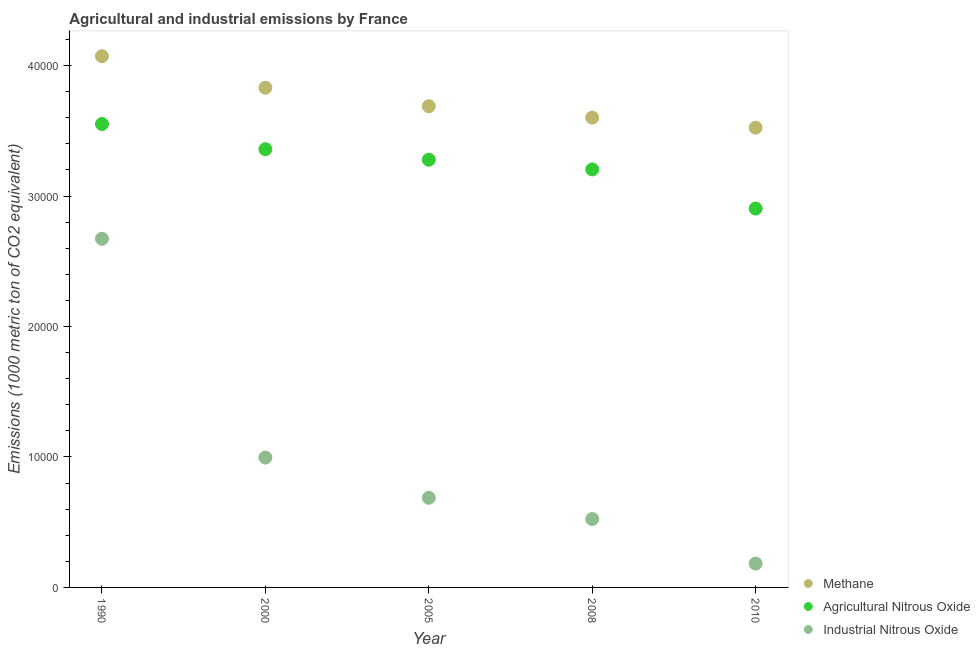How many different coloured dotlines are there?
Give a very brief answer. 3. Is the number of dotlines equal to the number of legend labels?
Your response must be concise. Yes. What is the amount of agricultural nitrous oxide emissions in 2005?
Make the answer very short. 3.28e+04. Across all years, what is the maximum amount of industrial nitrous oxide emissions?
Ensure brevity in your answer.  2.67e+04. Across all years, what is the minimum amount of methane emissions?
Ensure brevity in your answer.  3.52e+04. In which year was the amount of agricultural nitrous oxide emissions maximum?
Keep it short and to the point. 1990. In which year was the amount of industrial nitrous oxide emissions minimum?
Offer a very short reply. 2010. What is the total amount of methane emissions in the graph?
Your answer should be compact. 1.87e+05. What is the difference between the amount of industrial nitrous oxide emissions in 2005 and that in 2010?
Your response must be concise. 5042.8. What is the difference between the amount of methane emissions in 1990 and the amount of agricultural nitrous oxide emissions in 2000?
Your response must be concise. 7128.7. What is the average amount of agricultural nitrous oxide emissions per year?
Provide a succinct answer. 3.26e+04. In the year 1990, what is the difference between the amount of industrial nitrous oxide emissions and amount of agricultural nitrous oxide emissions?
Provide a short and direct response. -8797.6. In how many years, is the amount of agricultural nitrous oxide emissions greater than 12000 metric ton?
Your answer should be compact. 5. What is the ratio of the amount of agricultural nitrous oxide emissions in 1990 to that in 2010?
Keep it short and to the point. 1.22. Is the difference between the amount of industrial nitrous oxide emissions in 2000 and 2005 greater than the difference between the amount of agricultural nitrous oxide emissions in 2000 and 2005?
Keep it short and to the point. Yes. What is the difference between the highest and the second highest amount of industrial nitrous oxide emissions?
Make the answer very short. 1.68e+04. What is the difference between the highest and the lowest amount of agricultural nitrous oxide emissions?
Ensure brevity in your answer.  6479.5. Is the sum of the amount of methane emissions in 2005 and 2010 greater than the maximum amount of industrial nitrous oxide emissions across all years?
Offer a very short reply. Yes. Is the amount of industrial nitrous oxide emissions strictly greater than the amount of methane emissions over the years?
Your answer should be very brief. No. Is the amount of methane emissions strictly less than the amount of agricultural nitrous oxide emissions over the years?
Give a very brief answer. No. How many years are there in the graph?
Your answer should be compact. 5. Does the graph contain any zero values?
Ensure brevity in your answer.  No. Where does the legend appear in the graph?
Provide a short and direct response. Bottom right. How are the legend labels stacked?
Give a very brief answer. Vertical. What is the title of the graph?
Keep it short and to the point. Agricultural and industrial emissions by France. Does "Negligence towards kids" appear as one of the legend labels in the graph?
Ensure brevity in your answer.  No. What is the label or title of the X-axis?
Provide a succinct answer. Year. What is the label or title of the Y-axis?
Offer a very short reply. Emissions (1000 metric ton of CO2 equivalent). What is the Emissions (1000 metric ton of CO2 equivalent) of Methane in 1990?
Give a very brief answer. 4.07e+04. What is the Emissions (1000 metric ton of CO2 equivalent) of Agricultural Nitrous Oxide in 1990?
Keep it short and to the point. 3.55e+04. What is the Emissions (1000 metric ton of CO2 equivalent) of Industrial Nitrous Oxide in 1990?
Your response must be concise. 2.67e+04. What is the Emissions (1000 metric ton of CO2 equivalent) of Methane in 2000?
Make the answer very short. 3.83e+04. What is the Emissions (1000 metric ton of CO2 equivalent) in Agricultural Nitrous Oxide in 2000?
Offer a very short reply. 3.36e+04. What is the Emissions (1000 metric ton of CO2 equivalent) in Industrial Nitrous Oxide in 2000?
Ensure brevity in your answer.  9953.8. What is the Emissions (1000 metric ton of CO2 equivalent) in Methane in 2005?
Your answer should be compact. 3.69e+04. What is the Emissions (1000 metric ton of CO2 equivalent) of Agricultural Nitrous Oxide in 2005?
Provide a short and direct response. 3.28e+04. What is the Emissions (1000 metric ton of CO2 equivalent) of Industrial Nitrous Oxide in 2005?
Give a very brief answer. 6871.6. What is the Emissions (1000 metric ton of CO2 equivalent) in Methane in 2008?
Offer a very short reply. 3.60e+04. What is the Emissions (1000 metric ton of CO2 equivalent) of Agricultural Nitrous Oxide in 2008?
Provide a succinct answer. 3.20e+04. What is the Emissions (1000 metric ton of CO2 equivalent) in Industrial Nitrous Oxide in 2008?
Your answer should be very brief. 5241.3. What is the Emissions (1000 metric ton of CO2 equivalent) in Methane in 2010?
Ensure brevity in your answer.  3.52e+04. What is the Emissions (1000 metric ton of CO2 equivalent) in Agricultural Nitrous Oxide in 2010?
Your answer should be compact. 2.90e+04. What is the Emissions (1000 metric ton of CO2 equivalent) of Industrial Nitrous Oxide in 2010?
Your answer should be compact. 1828.8. Across all years, what is the maximum Emissions (1000 metric ton of CO2 equivalent) in Methane?
Give a very brief answer. 4.07e+04. Across all years, what is the maximum Emissions (1000 metric ton of CO2 equivalent) of Agricultural Nitrous Oxide?
Your answer should be compact. 3.55e+04. Across all years, what is the maximum Emissions (1000 metric ton of CO2 equivalent) of Industrial Nitrous Oxide?
Keep it short and to the point. 2.67e+04. Across all years, what is the minimum Emissions (1000 metric ton of CO2 equivalent) of Methane?
Ensure brevity in your answer.  3.52e+04. Across all years, what is the minimum Emissions (1000 metric ton of CO2 equivalent) in Agricultural Nitrous Oxide?
Offer a very short reply. 2.90e+04. Across all years, what is the minimum Emissions (1000 metric ton of CO2 equivalent) of Industrial Nitrous Oxide?
Ensure brevity in your answer.  1828.8. What is the total Emissions (1000 metric ton of CO2 equivalent) of Methane in the graph?
Your answer should be compact. 1.87e+05. What is the total Emissions (1000 metric ton of CO2 equivalent) of Agricultural Nitrous Oxide in the graph?
Offer a very short reply. 1.63e+05. What is the total Emissions (1000 metric ton of CO2 equivalent) of Industrial Nitrous Oxide in the graph?
Ensure brevity in your answer.  5.06e+04. What is the difference between the Emissions (1000 metric ton of CO2 equivalent) in Methane in 1990 and that in 2000?
Offer a very short reply. 2415.3. What is the difference between the Emissions (1000 metric ton of CO2 equivalent) in Agricultural Nitrous Oxide in 1990 and that in 2000?
Your answer should be very brief. 1930.3. What is the difference between the Emissions (1000 metric ton of CO2 equivalent) in Industrial Nitrous Oxide in 1990 and that in 2000?
Ensure brevity in your answer.  1.68e+04. What is the difference between the Emissions (1000 metric ton of CO2 equivalent) of Methane in 1990 and that in 2005?
Your answer should be compact. 3836.5. What is the difference between the Emissions (1000 metric ton of CO2 equivalent) of Agricultural Nitrous Oxide in 1990 and that in 2005?
Your response must be concise. 2736.8. What is the difference between the Emissions (1000 metric ton of CO2 equivalent) in Industrial Nitrous Oxide in 1990 and that in 2005?
Provide a short and direct response. 1.99e+04. What is the difference between the Emissions (1000 metric ton of CO2 equivalent) in Methane in 1990 and that in 2008?
Provide a short and direct response. 4704.7. What is the difference between the Emissions (1000 metric ton of CO2 equivalent) of Agricultural Nitrous Oxide in 1990 and that in 2008?
Ensure brevity in your answer.  3480.3. What is the difference between the Emissions (1000 metric ton of CO2 equivalent) of Industrial Nitrous Oxide in 1990 and that in 2008?
Keep it short and to the point. 2.15e+04. What is the difference between the Emissions (1000 metric ton of CO2 equivalent) in Methane in 1990 and that in 2010?
Provide a succinct answer. 5479. What is the difference between the Emissions (1000 metric ton of CO2 equivalent) in Agricultural Nitrous Oxide in 1990 and that in 2010?
Your answer should be very brief. 6479.5. What is the difference between the Emissions (1000 metric ton of CO2 equivalent) in Industrial Nitrous Oxide in 1990 and that in 2010?
Your answer should be compact. 2.49e+04. What is the difference between the Emissions (1000 metric ton of CO2 equivalent) in Methane in 2000 and that in 2005?
Offer a terse response. 1421.2. What is the difference between the Emissions (1000 metric ton of CO2 equivalent) in Agricultural Nitrous Oxide in 2000 and that in 2005?
Keep it short and to the point. 806.5. What is the difference between the Emissions (1000 metric ton of CO2 equivalent) in Industrial Nitrous Oxide in 2000 and that in 2005?
Provide a succinct answer. 3082.2. What is the difference between the Emissions (1000 metric ton of CO2 equivalent) in Methane in 2000 and that in 2008?
Your response must be concise. 2289.4. What is the difference between the Emissions (1000 metric ton of CO2 equivalent) in Agricultural Nitrous Oxide in 2000 and that in 2008?
Provide a short and direct response. 1550. What is the difference between the Emissions (1000 metric ton of CO2 equivalent) in Industrial Nitrous Oxide in 2000 and that in 2008?
Offer a terse response. 4712.5. What is the difference between the Emissions (1000 metric ton of CO2 equivalent) in Methane in 2000 and that in 2010?
Make the answer very short. 3063.7. What is the difference between the Emissions (1000 metric ton of CO2 equivalent) in Agricultural Nitrous Oxide in 2000 and that in 2010?
Your answer should be very brief. 4549.2. What is the difference between the Emissions (1000 metric ton of CO2 equivalent) in Industrial Nitrous Oxide in 2000 and that in 2010?
Your answer should be very brief. 8125. What is the difference between the Emissions (1000 metric ton of CO2 equivalent) of Methane in 2005 and that in 2008?
Provide a succinct answer. 868.2. What is the difference between the Emissions (1000 metric ton of CO2 equivalent) in Agricultural Nitrous Oxide in 2005 and that in 2008?
Provide a short and direct response. 743.5. What is the difference between the Emissions (1000 metric ton of CO2 equivalent) in Industrial Nitrous Oxide in 2005 and that in 2008?
Give a very brief answer. 1630.3. What is the difference between the Emissions (1000 metric ton of CO2 equivalent) in Methane in 2005 and that in 2010?
Give a very brief answer. 1642.5. What is the difference between the Emissions (1000 metric ton of CO2 equivalent) in Agricultural Nitrous Oxide in 2005 and that in 2010?
Your answer should be very brief. 3742.7. What is the difference between the Emissions (1000 metric ton of CO2 equivalent) in Industrial Nitrous Oxide in 2005 and that in 2010?
Provide a succinct answer. 5042.8. What is the difference between the Emissions (1000 metric ton of CO2 equivalent) in Methane in 2008 and that in 2010?
Keep it short and to the point. 774.3. What is the difference between the Emissions (1000 metric ton of CO2 equivalent) in Agricultural Nitrous Oxide in 2008 and that in 2010?
Your answer should be compact. 2999.2. What is the difference between the Emissions (1000 metric ton of CO2 equivalent) of Industrial Nitrous Oxide in 2008 and that in 2010?
Your response must be concise. 3412.5. What is the difference between the Emissions (1000 metric ton of CO2 equivalent) of Methane in 1990 and the Emissions (1000 metric ton of CO2 equivalent) of Agricultural Nitrous Oxide in 2000?
Offer a very short reply. 7128.7. What is the difference between the Emissions (1000 metric ton of CO2 equivalent) of Methane in 1990 and the Emissions (1000 metric ton of CO2 equivalent) of Industrial Nitrous Oxide in 2000?
Give a very brief answer. 3.08e+04. What is the difference between the Emissions (1000 metric ton of CO2 equivalent) of Agricultural Nitrous Oxide in 1990 and the Emissions (1000 metric ton of CO2 equivalent) of Industrial Nitrous Oxide in 2000?
Provide a short and direct response. 2.56e+04. What is the difference between the Emissions (1000 metric ton of CO2 equivalent) of Methane in 1990 and the Emissions (1000 metric ton of CO2 equivalent) of Agricultural Nitrous Oxide in 2005?
Your response must be concise. 7935.2. What is the difference between the Emissions (1000 metric ton of CO2 equivalent) in Methane in 1990 and the Emissions (1000 metric ton of CO2 equivalent) in Industrial Nitrous Oxide in 2005?
Offer a very short reply. 3.38e+04. What is the difference between the Emissions (1000 metric ton of CO2 equivalent) of Agricultural Nitrous Oxide in 1990 and the Emissions (1000 metric ton of CO2 equivalent) of Industrial Nitrous Oxide in 2005?
Offer a very short reply. 2.86e+04. What is the difference between the Emissions (1000 metric ton of CO2 equivalent) in Methane in 1990 and the Emissions (1000 metric ton of CO2 equivalent) in Agricultural Nitrous Oxide in 2008?
Offer a terse response. 8678.7. What is the difference between the Emissions (1000 metric ton of CO2 equivalent) in Methane in 1990 and the Emissions (1000 metric ton of CO2 equivalent) in Industrial Nitrous Oxide in 2008?
Provide a short and direct response. 3.55e+04. What is the difference between the Emissions (1000 metric ton of CO2 equivalent) of Agricultural Nitrous Oxide in 1990 and the Emissions (1000 metric ton of CO2 equivalent) of Industrial Nitrous Oxide in 2008?
Your answer should be very brief. 3.03e+04. What is the difference between the Emissions (1000 metric ton of CO2 equivalent) of Methane in 1990 and the Emissions (1000 metric ton of CO2 equivalent) of Agricultural Nitrous Oxide in 2010?
Offer a terse response. 1.17e+04. What is the difference between the Emissions (1000 metric ton of CO2 equivalent) of Methane in 1990 and the Emissions (1000 metric ton of CO2 equivalent) of Industrial Nitrous Oxide in 2010?
Your response must be concise. 3.89e+04. What is the difference between the Emissions (1000 metric ton of CO2 equivalent) of Agricultural Nitrous Oxide in 1990 and the Emissions (1000 metric ton of CO2 equivalent) of Industrial Nitrous Oxide in 2010?
Ensure brevity in your answer.  3.37e+04. What is the difference between the Emissions (1000 metric ton of CO2 equivalent) of Methane in 2000 and the Emissions (1000 metric ton of CO2 equivalent) of Agricultural Nitrous Oxide in 2005?
Give a very brief answer. 5519.9. What is the difference between the Emissions (1000 metric ton of CO2 equivalent) of Methane in 2000 and the Emissions (1000 metric ton of CO2 equivalent) of Industrial Nitrous Oxide in 2005?
Keep it short and to the point. 3.14e+04. What is the difference between the Emissions (1000 metric ton of CO2 equivalent) in Agricultural Nitrous Oxide in 2000 and the Emissions (1000 metric ton of CO2 equivalent) in Industrial Nitrous Oxide in 2005?
Keep it short and to the point. 2.67e+04. What is the difference between the Emissions (1000 metric ton of CO2 equivalent) of Methane in 2000 and the Emissions (1000 metric ton of CO2 equivalent) of Agricultural Nitrous Oxide in 2008?
Your response must be concise. 6263.4. What is the difference between the Emissions (1000 metric ton of CO2 equivalent) of Methane in 2000 and the Emissions (1000 metric ton of CO2 equivalent) of Industrial Nitrous Oxide in 2008?
Keep it short and to the point. 3.31e+04. What is the difference between the Emissions (1000 metric ton of CO2 equivalent) in Agricultural Nitrous Oxide in 2000 and the Emissions (1000 metric ton of CO2 equivalent) in Industrial Nitrous Oxide in 2008?
Offer a very short reply. 2.83e+04. What is the difference between the Emissions (1000 metric ton of CO2 equivalent) of Methane in 2000 and the Emissions (1000 metric ton of CO2 equivalent) of Agricultural Nitrous Oxide in 2010?
Your answer should be compact. 9262.6. What is the difference between the Emissions (1000 metric ton of CO2 equivalent) in Methane in 2000 and the Emissions (1000 metric ton of CO2 equivalent) in Industrial Nitrous Oxide in 2010?
Offer a terse response. 3.65e+04. What is the difference between the Emissions (1000 metric ton of CO2 equivalent) in Agricultural Nitrous Oxide in 2000 and the Emissions (1000 metric ton of CO2 equivalent) in Industrial Nitrous Oxide in 2010?
Provide a short and direct response. 3.18e+04. What is the difference between the Emissions (1000 metric ton of CO2 equivalent) of Methane in 2005 and the Emissions (1000 metric ton of CO2 equivalent) of Agricultural Nitrous Oxide in 2008?
Your answer should be very brief. 4842.2. What is the difference between the Emissions (1000 metric ton of CO2 equivalent) of Methane in 2005 and the Emissions (1000 metric ton of CO2 equivalent) of Industrial Nitrous Oxide in 2008?
Offer a very short reply. 3.16e+04. What is the difference between the Emissions (1000 metric ton of CO2 equivalent) in Agricultural Nitrous Oxide in 2005 and the Emissions (1000 metric ton of CO2 equivalent) in Industrial Nitrous Oxide in 2008?
Provide a succinct answer. 2.75e+04. What is the difference between the Emissions (1000 metric ton of CO2 equivalent) of Methane in 2005 and the Emissions (1000 metric ton of CO2 equivalent) of Agricultural Nitrous Oxide in 2010?
Give a very brief answer. 7841.4. What is the difference between the Emissions (1000 metric ton of CO2 equivalent) of Methane in 2005 and the Emissions (1000 metric ton of CO2 equivalent) of Industrial Nitrous Oxide in 2010?
Make the answer very short. 3.51e+04. What is the difference between the Emissions (1000 metric ton of CO2 equivalent) in Agricultural Nitrous Oxide in 2005 and the Emissions (1000 metric ton of CO2 equivalent) in Industrial Nitrous Oxide in 2010?
Give a very brief answer. 3.10e+04. What is the difference between the Emissions (1000 metric ton of CO2 equivalent) of Methane in 2008 and the Emissions (1000 metric ton of CO2 equivalent) of Agricultural Nitrous Oxide in 2010?
Your answer should be compact. 6973.2. What is the difference between the Emissions (1000 metric ton of CO2 equivalent) of Methane in 2008 and the Emissions (1000 metric ton of CO2 equivalent) of Industrial Nitrous Oxide in 2010?
Make the answer very short. 3.42e+04. What is the difference between the Emissions (1000 metric ton of CO2 equivalent) in Agricultural Nitrous Oxide in 2008 and the Emissions (1000 metric ton of CO2 equivalent) in Industrial Nitrous Oxide in 2010?
Give a very brief answer. 3.02e+04. What is the average Emissions (1000 metric ton of CO2 equivalent) in Methane per year?
Offer a terse response. 3.74e+04. What is the average Emissions (1000 metric ton of CO2 equivalent) in Agricultural Nitrous Oxide per year?
Offer a very short reply. 3.26e+04. What is the average Emissions (1000 metric ton of CO2 equivalent) in Industrial Nitrous Oxide per year?
Your answer should be compact. 1.01e+04. In the year 1990, what is the difference between the Emissions (1000 metric ton of CO2 equivalent) in Methane and Emissions (1000 metric ton of CO2 equivalent) in Agricultural Nitrous Oxide?
Your response must be concise. 5198.4. In the year 1990, what is the difference between the Emissions (1000 metric ton of CO2 equivalent) in Methane and Emissions (1000 metric ton of CO2 equivalent) in Industrial Nitrous Oxide?
Provide a short and direct response. 1.40e+04. In the year 1990, what is the difference between the Emissions (1000 metric ton of CO2 equivalent) in Agricultural Nitrous Oxide and Emissions (1000 metric ton of CO2 equivalent) in Industrial Nitrous Oxide?
Provide a short and direct response. 8797.6. In the year 2000, what is the difference between the Emissions (1000 metric ton of CO2 equivalent) in Methane and Emissions (1000 metric ton of CO2 equivalent) in Agricultural Nitrous Oxide?
Your answer should be very brief. 4713.4. In the year 2000, what is the difference between the Emissions (1000 metric ton of CO2 equivalent) in Methane and Emissions (1000 metric ton of CO2 equivalent) in Industrial Nitrous Oxide?
Your response must be concise. 2.83e+04. In the year 2000, what is the difference between the Emissions (1000 metric ton of CO2 equivalent) of Agricultural Nitrous Oxide and Emissions (1000 metric ton of CO2 equivalent) of Industrial Nitrous Oxide?
Provide a short and direct response. 2.36e+04. In the year 2005, what is the difference between the Emissions (1000 metric ton of CO2 equivalent) in Methane and Emissions (1000 metric ton of CO2 equivalent) in Agricultural Nitrous Oxide?
Offer a terse response. 4098.7. In the year 2005, what is the difference between the Emissions (1000 metric ton of CO2 equivalent) of Methane and Emissions (1000 metric ton of CO2 equivalent) of Industrial Nitrous Oxide?
Offer a terse response. 3.00e+04. In the year 2005, what is the difference between the Emissions (1000 metric ton of CO2 equivalent) of Agricultural Nitrous Oxide and Emissions (1000 metric ton of CO2 equivalent) of Industrial Nitrous Oxide?
Keep it short and to the point. 2.59e+04. In the year 2008, what is the difference between the Emissions (1000 metric ton of CO2 equivalent) in Methane and Emissions (1000 metric ton of CO2 equivalent) in Agricultural Nitrous Oxide?
Offer a very short reply. 3974. In the year 2008, what is the difference between the Emissions (1000 metric ton of CO2 equivalent) of Methane and Emissions (1000 metric ton of CO2 equivalent) of Industrial Nitrous Oxide?
Offer a very short reply. 3.08e+04. In the year 2008, what is the difference between the Emissions (1000 metric ton of CO2 equivalent) in Agricultural Nitrous Oxide and Emissions (1000 metric ton of CO2 equivalent) in Industrial Nitrous Oxide?
Your answer should be compact. 2.68e+04. In the year 2010, what is the difference between the Emissions (1000 metric ton of CO2 equivalent) in Methane and Emissions (1000 metric ton of CO2 equivalent) in Agricultural Nitrous Oxide?
Offer a very short reply. 6198.9. In the year 2010, what is the difference between the Emissions (1000 metric ton of CO2 equivalent) in Methane and Emissions (1000 metric ton of CO2 equivalent) in Industrial Nitrous Oxide?
Your response must be concise. 3.34e+04. In the year 2010, what is the difference between the Emissions (1000 metric ton of CO2 equivalent) of Agricultural Nitrous Oxide and Emissions (1000 metric ton of CO2 equivalent) of Industrial Nitrous Oxide?
Ensure brevity in your answer.  2.72e+04. What is the ratio of the Emissions (1000 metric ton of CO2 equivalent) in Methane in 1990 to that in 2000?
Your answer should be compact. 1.06. What is the ratio of the Emissions (1000 metric ton of CO2 equivalent) in Agricultural Nitrous Oxide in 1990 to that in 2000?
Your response must be concise. 1.06. What is the ratio of the Emissions (1000 metric ton of CO2 equivalent) of Industrial Nitrous Oxide in 1990 to that in 2000?
Provide a short and direct response. 2.68. What is the ratio of the Emissions (1000 metric ton of CO2 equivalent) in Methane in 1990 to that in 2005?
Make the answer very short. 1.1. What is the ratio of the Emissions (1000 metric ton of CO2 equivalent) in Agricultural Nitrous Oxide in 1990 to that in 2005?
Your answer should be very brief. 1.08. What is the ratio of the Emissions (1000 metric ton of CO2 equivalent) of Industrial Nitrous Oxide in 1990 to that in 2005?
Provide a short and direct response. 3.89. What is the ratio of the Emissions (1000 metric ton of CO2 equivalent) of Methane in 1990 to that in 2008?
Make the answer very short. 1.13. What is the ratio of the Emissions (1000 metric ton of CO2 equivalent) in Agricultural Nitrous Oxide in 1990 to that in 2008?
Give a very brief answer. 1.11. What is the ratio of the Emissions (1000 metric ton of CO2 equivalent) in Industrial Nitrous Oxide in 1990 to that in 2008?
Give a very brief answer. 5.1. What is the ratio of the Emissions (1000 metric ton of CO2 equivalent) of Methane in 1990 to that in 2010?
Offer a terse response. 1.16. What is the ratio of the Emissions (1000 metric ton of CO2 equivalent) in Agricultural Nitrous Oxide in 1990 to that in 2010?
Offer a terse response. 1.22. What is the ratio of the Emissions (1000 metric ton of CO2 equivalent) of Industrial Nitrous Oxide in 1990 to that in 2010?
Your response must be concise. 14.61. What is the ratio of the Emissions (1000 metric ton of CO2 equivalent) of Agricultural Nitrous Oxide in 2000 to that in 2005?
Offer a very short reply. 1.02. What is the ratio of the Emissions (1000 metric ton of CO2 equivalent) of Industrial Nitrous Oxide in 2000 to that in 2005?
Give a very brief answer. 1.45. What is the ratio of the Emissions (1000 metric ton of CO2 equivalent) of Methane in 2000 to that in 2008?
Offer a terse response. 1.06. What is the ratio of the Emissions (1000 metric ton of CO2 equivalent) of Agricultural Nitrous Oxide in 2000 to that in 2008?
Keep it short and to the point. 1.05. What is the ratio of the Emissions (1000 metric ton of CO2 equivalent) in Industrial Nitrous Oxide in 2000 to that in 2008?
Your answer should be compact. 1.9. What is the ratio of the Emissions (1000 metric ton of CO2 equivalent) of Methane in 2000 to that in 2010?
Ensure brevity in your answer.  1.09. What is the ratio of the Emissions (1000 metric ton of CO2 equivalent) in Agricultural Nitrous Oxide in 2000 to that in 2010?
Offer a terse response. 1.16. What is the ratio of the Emissions (1000 metric ton of CO2 equivalent) of Industrial Nitrous Oxide in 2000 to that in 2010?
Provide a short and direct response. 5.44. What is the ratio of the Emissions (1000 metric ton of CO2 equivalent) in Methane in 2005 to that in 2008?
Provide a succinct answer. 1.02. What is the ratio of the Emissions (1000 metric ton of CO2 equivalent) in Agricultural Nitrous Oxide in 2005 to that in 2008?
Keep it short and to the point. 1.02. What is the ratio of the Emissions (1000 metric ton of CO2 equivalent) in Industrial Nitrous Oxide in 2005 to that in 2008?
Give a very brief answer. 1.31. What is the ratio of the Emissions (1000 metric ton of CO2 equivalent) of Methane in 2005 to that in 2010?
Offer a very short reply. 1.05. What is the ratio of the Emissions (1000 metric ton of CO2 equivalent) of Agricultural Nitrous Oxide in 2005 to that in 2010?
Your answer should be compact. 1.13. What is the ratio of the Emissions (1000 metric ton of CO2 equivalent) of Industrial Nitrous Oxide in 2005 to that in 2010?
Ensure brevity in your answer.  3.76. What is the ratio of the Emissions (1000 metric ton of CO2 equivalent) in Agricultural Nitrous Oxide in 2008 to that in 2010?
Offer a very short reply. 1.1. What is the ratio of the Emissions (1000 metric ton of CO2 equivalent) in Industrial Nitrous Oxide in 2008 to that in 2010?
Your answer should be compact. 2.87. What is the difference between the highest and the second highest Emissions (1000 metric ton of CO2 equivalent) of Methane?
Your response must be concise. 2415.3. What is the difference between the highest and the second highest Emissions (1000 metric ton of CO2 equivalent) of Agricultural Nitrous Oxide?
Offer a very short reply. 1930.3. What is the difference between the highest and the second highest Emissions (1000 metric ton of CO2 equivalent) in Industrial Nitrous Oxide?
Your answer should be compact. 1.68e+04. What is the difference between the highest and the lowest Emissions (1000 metric ton of CO2 equivalent) in Methane?
Your answer should be very brief. 5479. What is the difference between the highest and the lowest Emissions (1000 metric ton of CO2 equivalent) in Agricultural Nitrous Oxide?
Provide a succinct answer. 6479.5. What is the difference between the highest and the lowest Emissions (1000 metric ton of CO2 equivalent) in Industrial Nitrous Oxide?
Give a very brief answer. 2.49e+04. 